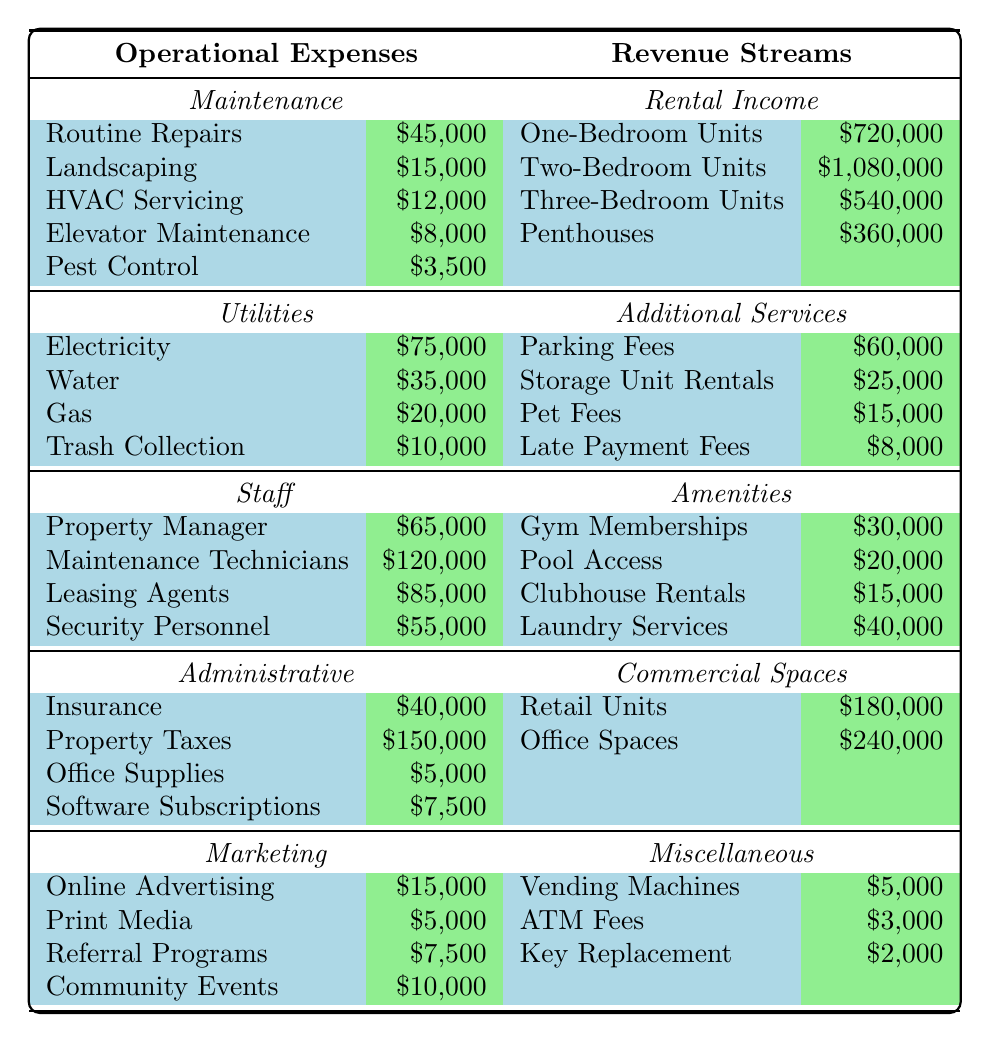What is the total maintenance cost? The maintenance costs are Routine Repairs ($45,000), Landscaping ($15,000), HVAC Servicing ($12,000), Elevator Maintenance ($8,000), and Pest Control ($3,500). Adding these gives: 45,000 + 15,000 + 12,000 + 8,000 + 3,500 = $83,500.
Answer: $83,500 What is the revenue from two-bedroom units? The revenue from two-bedroom units is stated directly in the table as $1,080,000.
Answer: $1,080,000 How much do utilities cost in total? The utilities costs are Electricity ($75,000), Water ($35,000), Gas ($20,000), and Trash Collection ($10,000). The total is 75,000 + 35,000 + 20,000 + 10,000 = $140,000.
Answer: $140,000 Which operational expense category has the highest total cost? First, calculate the total for each operational expense category: Maintenance ($83,500), Utilities ($140,000), Staff ($320,000), Administrative ($199,500), Marketing ($37,500). The Staff category has the highest total cost at $320,000.
Answer: Staff What is the total revenue from additional services? The revenue from additional services includes Parking Fees ($60,000), Storage Unit Rentals ($25,000), Pet Fees ($15,000), and Late Payment Fees ($8,000). Summing these gives: 60,000 + 25,000 + 15,000 + 8,000 = $108,000.
Answer: $108,000 Is the total revenue from retail units higher than the total cost of insurance? The revenue from retail units is $180,000, and the cost of insurance is $40,000. Since $180,000 is greater than $40,000, the answer is yes.
Answer: Yes What percentage of total operational expenses is spent on staff? Total operational expenses calculated are $83,500 (Maintenance) + $140,000 (Utilities) + $320,000 (Staff) + $199,500 (Administrative) + $37,500 (Marketing) = $780,500. The staff cost is $320,000. The percentage is (320,000 / 780,500) * 100 ≈ 40.98%.
Answer: Approximately 40.98% What is the total revenue including all streams? Total revenue consists of Rental Income ($2,880,000), Additional Services ($108,000), Amenities ($105,000), Commercial Spaces ($420,000), and Miscellaneous ($10,000). Summing these gives: 2,880,000 + 108,000 + 105,000 + 420,000 + 10,000 = $3,523,000.
Answer: $3,523,000 What is the difference between total administrative costs and total maintenance costs? The total administrative costs are $199,500 and the total maintenance costs are $83,500. The difference is $199,500 - $83,500 = $116,000.
Answer: $116,000 What is the average revenue per type of rental unit? The rental income from One-Bedroom Units ($720,000), Two-Bedroom Units ($1,080,000), Three-Bedroom Units ($540,000), and Penthouses ($360,000). There are 4 types, the average is (720,000 + 1,080,000 + 540,000 + 360,000) / 4 = $675,000.
Answer: $675,000 